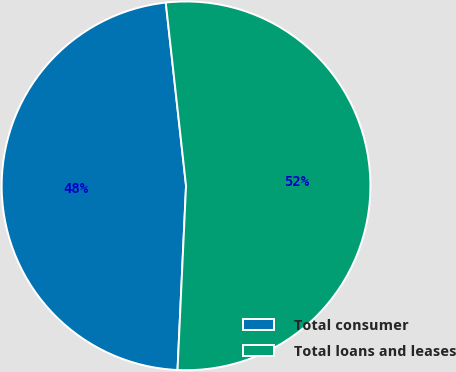<chart> <loc_0><loc_0><loc_500><loc_500><pie_chart><fcel>Total consumer<fcel>Total loans and leases<nl><fcel>47.51%<fcel>52.49%<nl></chart> 